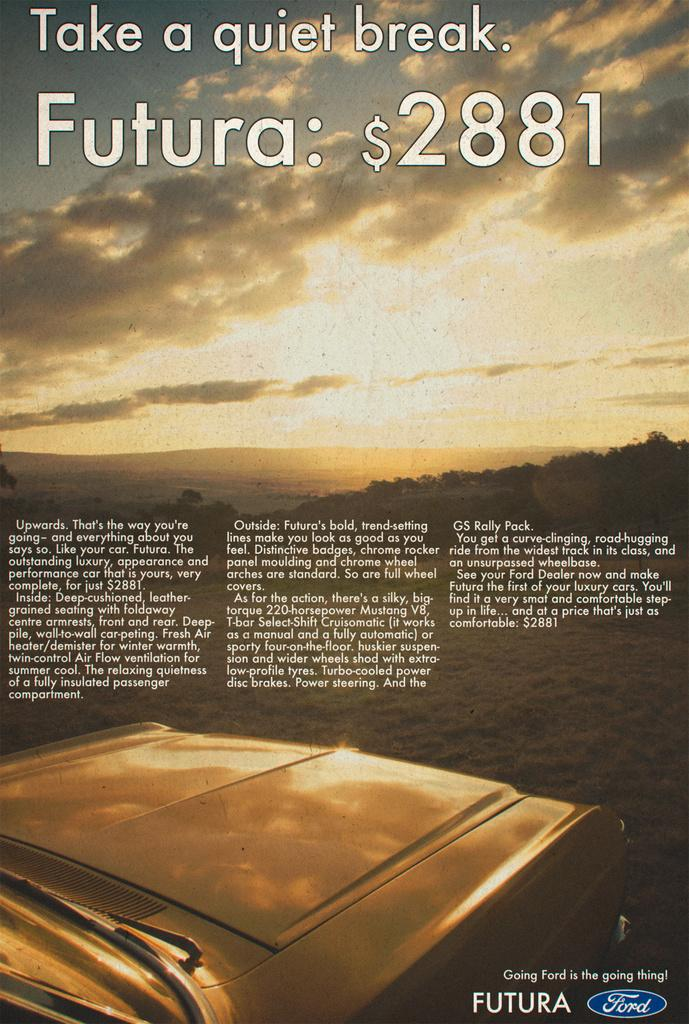<image>
Provide a brief description of the given image. An advertisement for Futura vehicles, made by Ford. 